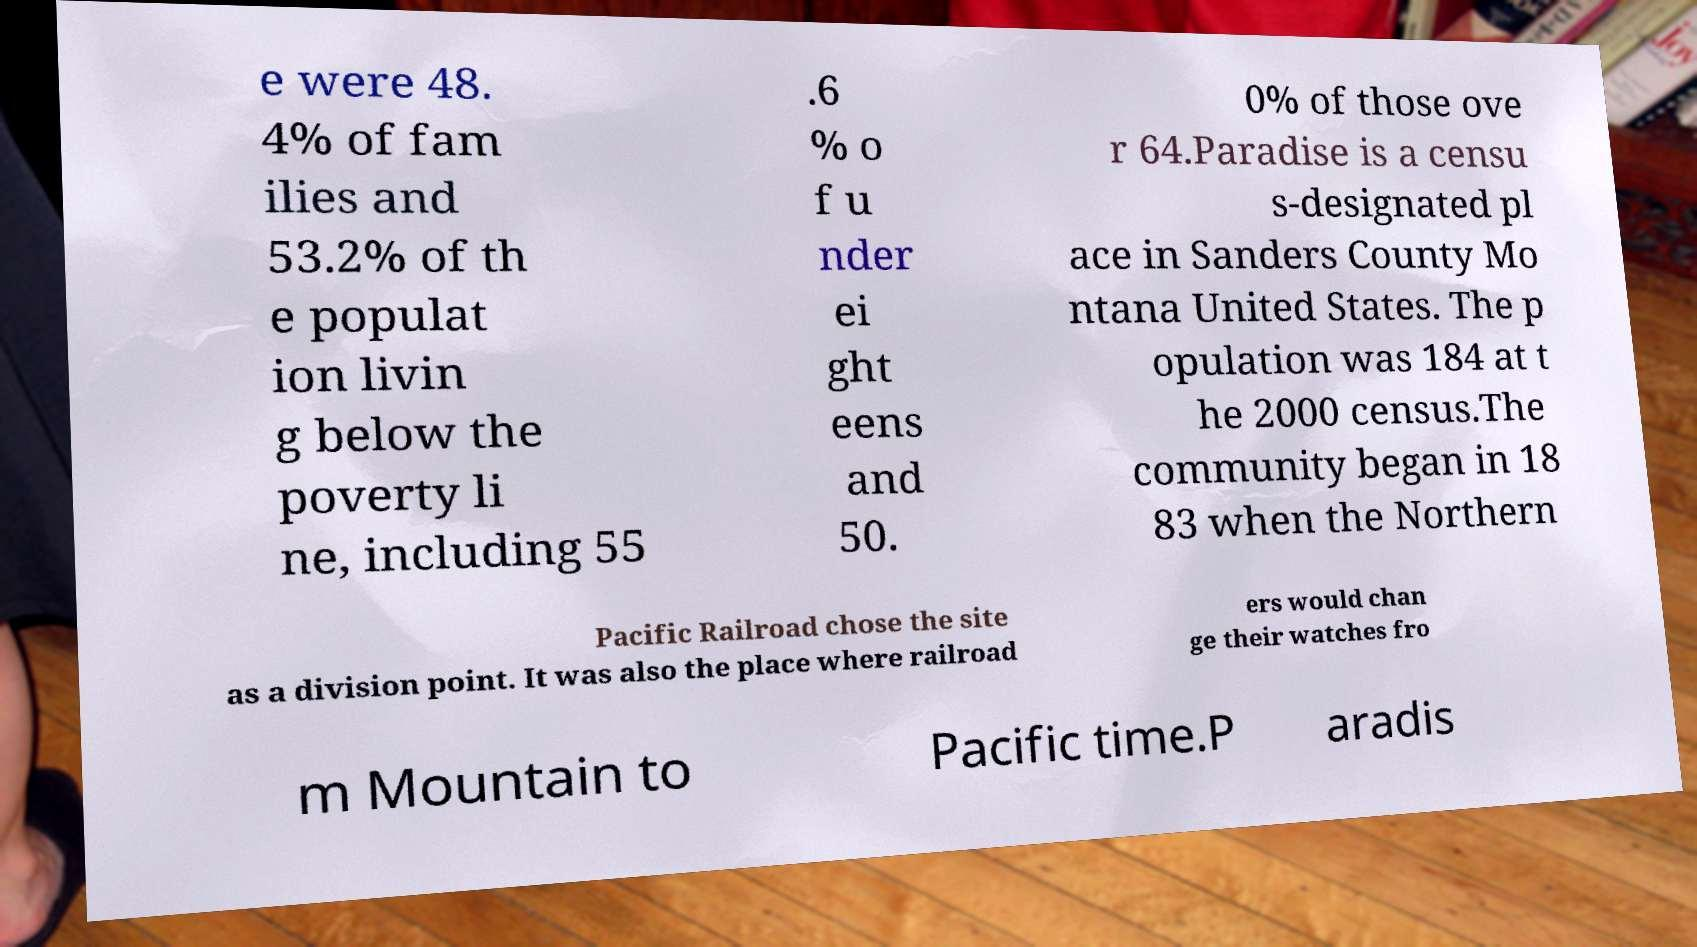Please identify and transcribe the text found in this image. e were 48. 4% of fam ilies and 53.2% of th e populat ion livin g below the poverty li ne, including 55 .6 % o f u nder ei ght eens and 50. 0% of those ove r 64.Paradise is a censu s-designated pl ace in Sanders County Mo ntana United States. The p opulation was 184 at t he 2000 census.The community began in 18 83 when the Northern Pacific Railroad chose the site as a division point. It was also the place where railroad ers would chan ge their watches fro m Mountain to Pacific time.P aradis 